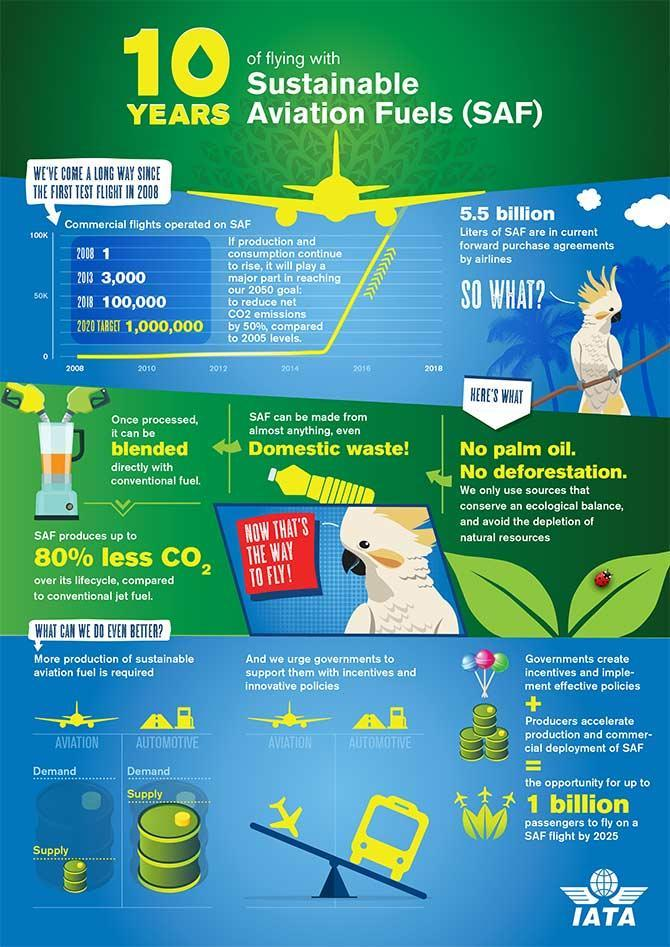What is the total number of flights in 2013 and 2018 together?
Answer the question with a short phrase. 103000 